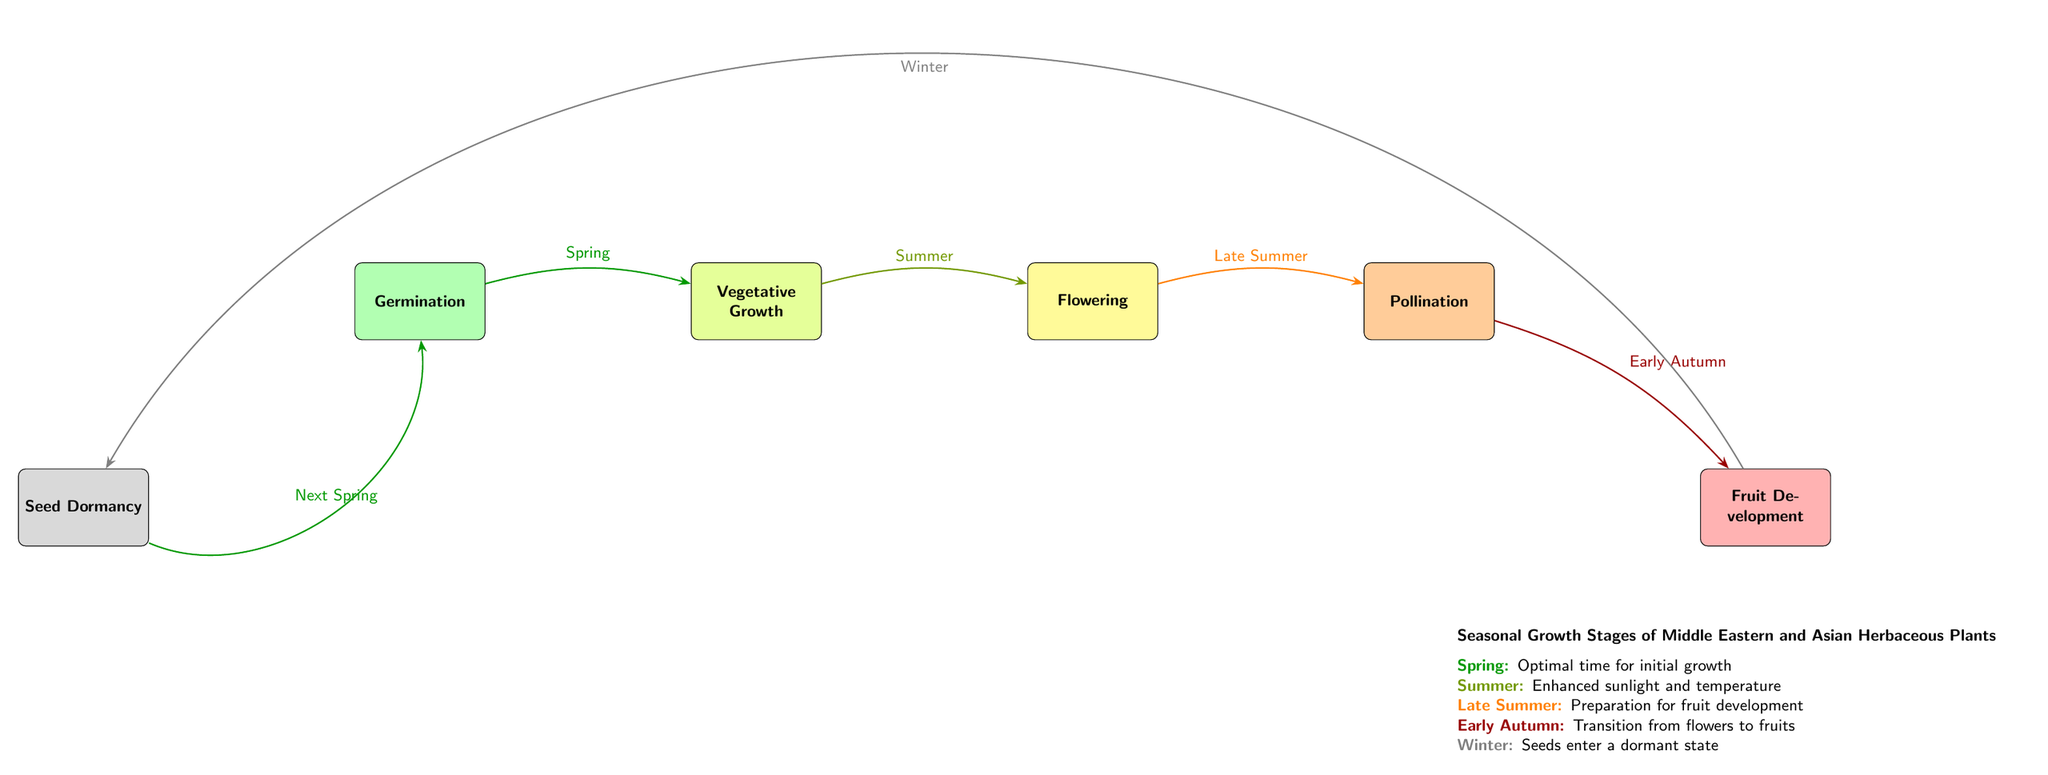What is the first growth stage for these plants? The diagram indicates that the first growth stage for Middle Eastern and Asian herbaceous plants is "Germination." This is the starting point of their seasonal growth stages.
Answer: Germination How many main growth stages are represented in the diagram? The diagram shows six main growth stages: Germination, Vegetative Growth, Flowering, Pollination, Fruit Development, and Seed Dormancy. By counting these stages, the total is confirmed.
Answer: 6 What season correlates with the Pollination stage? According to the diagram, the Pollination stage is linked with "Early Autumn." This is indicated by the directed edge that moves from Flowering to Pollination, labeled as Early Autumn.
Answer: Early Autumn Which stage follows Vegetative Growth? The diagram illustrates that the stage following Vegetative Growth is "Flowering," as indicated by the directed edge leading from the Vegetative Growth node to the Flowering node.
Answer: Flowering What color represents the Winter dormancy period? In the diagram, the Winter dormancy period is represented by the color gray. This color is used for the Seed Dormancy stage, which occurs during winter.
Answer: Gray Which stage occurs during Summer? The stage that takes place during Summer is "Vegetative Growth," as depicted by the edge labeled "Summer" connecting Germination and Vegetative Growth.
Answer: Vegetative Growth What happens after the Fruit Development stage? After the Fruit Development stage, the seeds enter "Seed Dormancy" during Winter, as shown by the directed edge linking the Fruit Development node to the Seed Dormancy node.
Answer: Seed Dormancy How does the transition from Flowering to Pollination occur? The transition from Flowering to Pollination is marked by the "Late Summer" label on the edge leading from Flowering to Pollination. This indicates the time frame in which this transition takes place.
Answer: Late Summer Which stage is marked in red? The stage marked in red is "Fruit Development," indicating a significant phase in the growth cycle of the plants, occurring after Pollination.
Answer: Fruit Development 